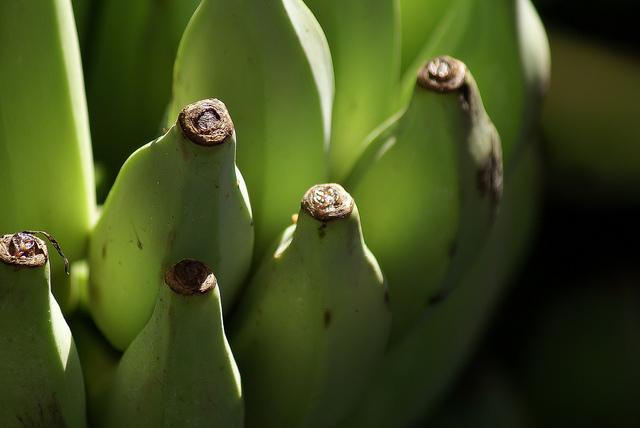Are these ripe?
Concise answer only. No. What color are the bananas?
Give a very brief answer. Green. Is this picture a close up?
Answer briefly. Yes. 